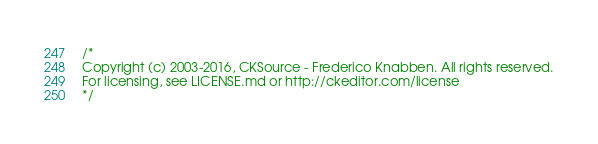Convert code to text. <code><loc_0><loc_0><loc_500><loc_500><_CSS_>/*
Copyright (c) 2003-2016, CKSource - Frederico Knabben. All rights reserved.
For licensing, see LICENSE.md or http://ckeditor.com/license
*/</code> 